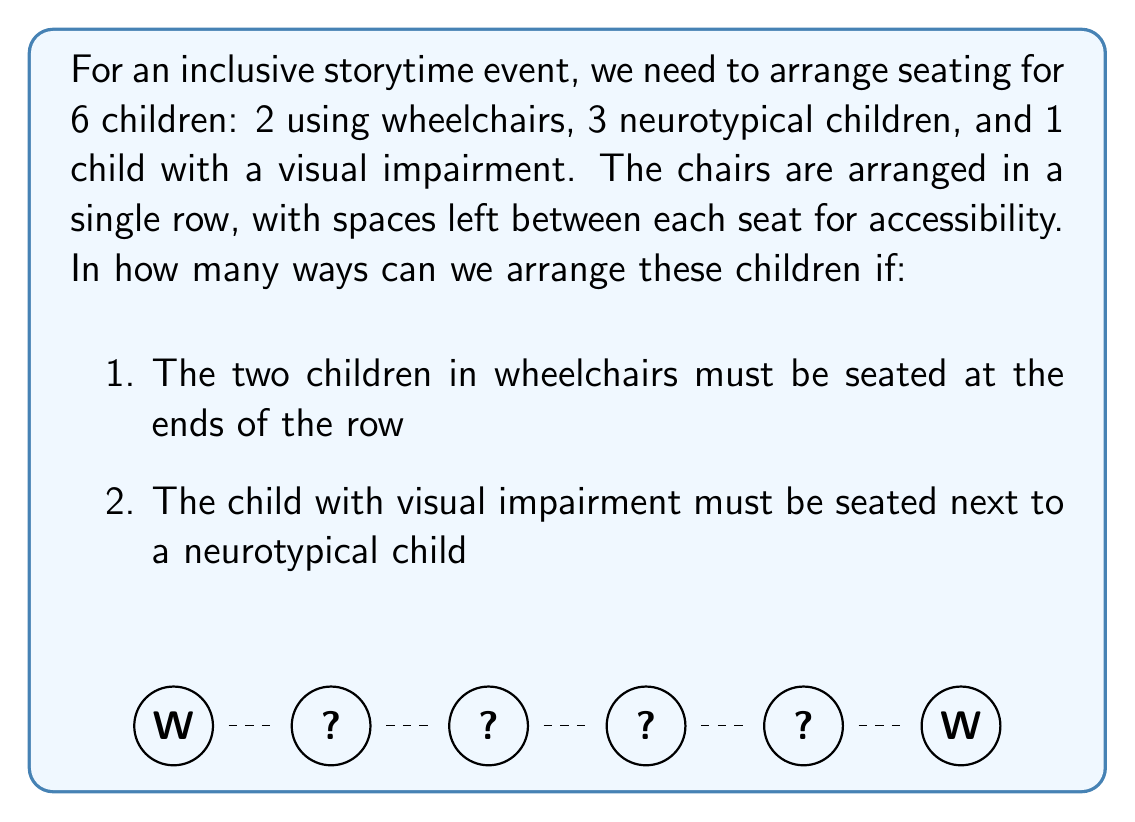What is the answer to this math problem? Let's approach this step-by-step:

1) First, we know that the two wheelchair users must be at the ends. This leaves 4 seats in the middle to arrange.

2) We need to ensure the visually impaired child is next to a neurotypical child. We can consider this pair as a single unit. So now we have 3 units to arrange: 2 individual neurotypical children and 1 pair (visually impaired + neurotypical).

3) The number of ways to arrange 3 distinct units is $3! = 6$.

4) However, for each of these 6 arrangements, the visually impaired child and their neurotypical partner can swap positions. This doubles our possibilities.

5) Therefore, the total number of arrangements is:

   $$6 \times 2 = 12$$

6) We can verify this by listing all possibilities:
   - W (V N) N N W
   - W (N V) N N W
   - W N (V N) N W
   - W N (N V) N W
   - W N N (V N) W
   - W N N (N V) W
   - W (V N) N N W
   - W (N V) N N W
   - W N (V N) N W
   - W N (N V) N W
   - W N N (V N) W
   - W N N (N V) W

   Where W = wheelchair user, V = visually impaired, N = neurotypical

Thus, there are 12 possible seating arrangements that satisfy all conditions.
Answer: 12 arrangements 